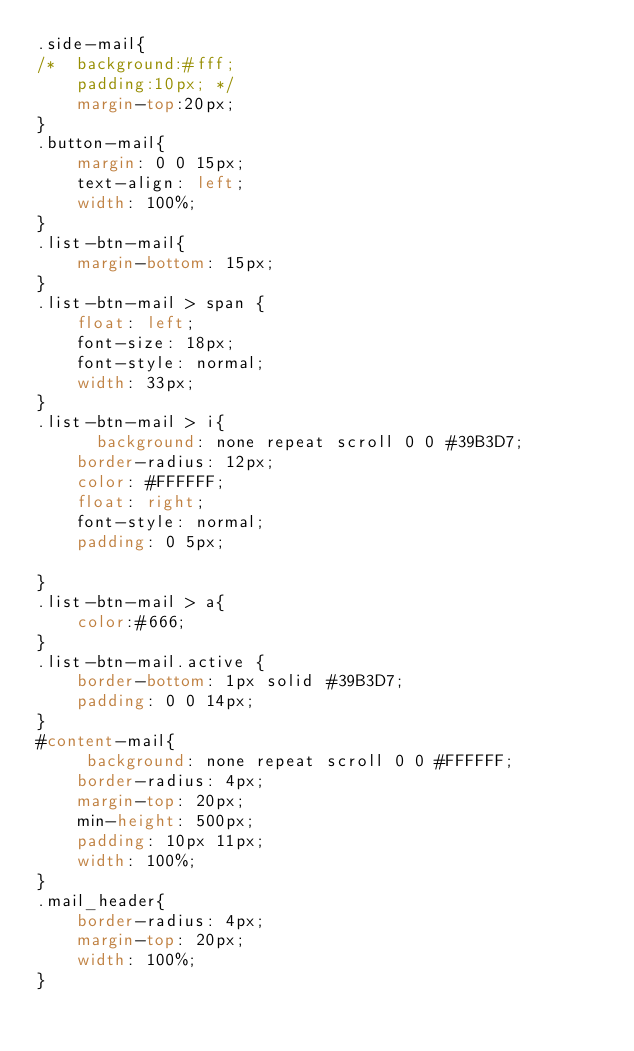<code> <loc_0><loc_0><loc_500><loc_500><_CSS_>.side-mail{
/* 	background:#fff;
	padding:10px; */
	margin-top:20px;
}
.button-mail{
	margin: 0 0 15px;
    text-align: left;
    width: 100%;
}
.list-btn-mail{
	margin-bottom: 15px;
}
.list-btn-mail > span {
	float: left;
    font-size: 18px;
    font-style: normal;
    width: 33px;
}
.list-btn-mail > i{	
	  background: none repeat scroll 0 0 #39B3D7;
    border-radius: 12px;
    color: #FFFFFF;
    float: right;
    font-style: normal;
    padding: 0 5px;
	
}
.list-btn-mail > a{
	color:#666;	
}
.list-btn-mail.active {
    border-bottom: 1px solid #39B3D7;
    padding: 0 0 14px;
}
#content-mail{
	 background: none repeat scroll 0 0 #FFFFFF;
    border-radius: 4px;
    margin-top: 20px;
    min-height: 500px;
    padding: 10px 11px;
    width: 100%;
}
.mail_header{
    border-radius: 4px;
    margin-top: 20px;
    width: 100%;
}</code> 